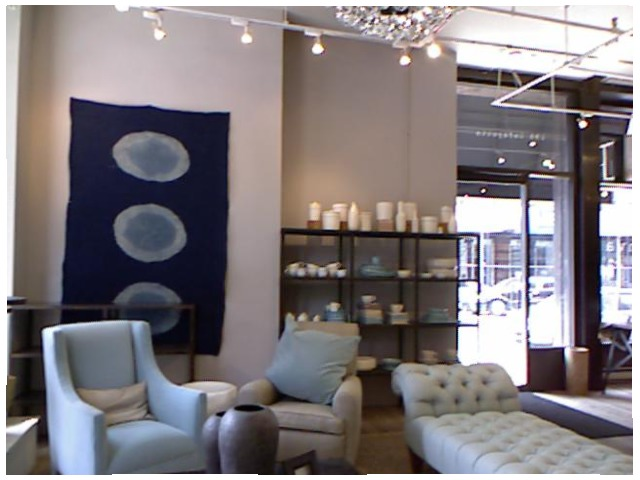<image>
Can you confirm if the rug is on the wall? Yes. Looking at the image, I can see the rug is positioned on top of the wall, with the wall providing support. Is there a sofa behind the wall? No. The sofa is not behind the wall. From this viewpoint, the sofa appears to be positioned elsewhere in the scene. 